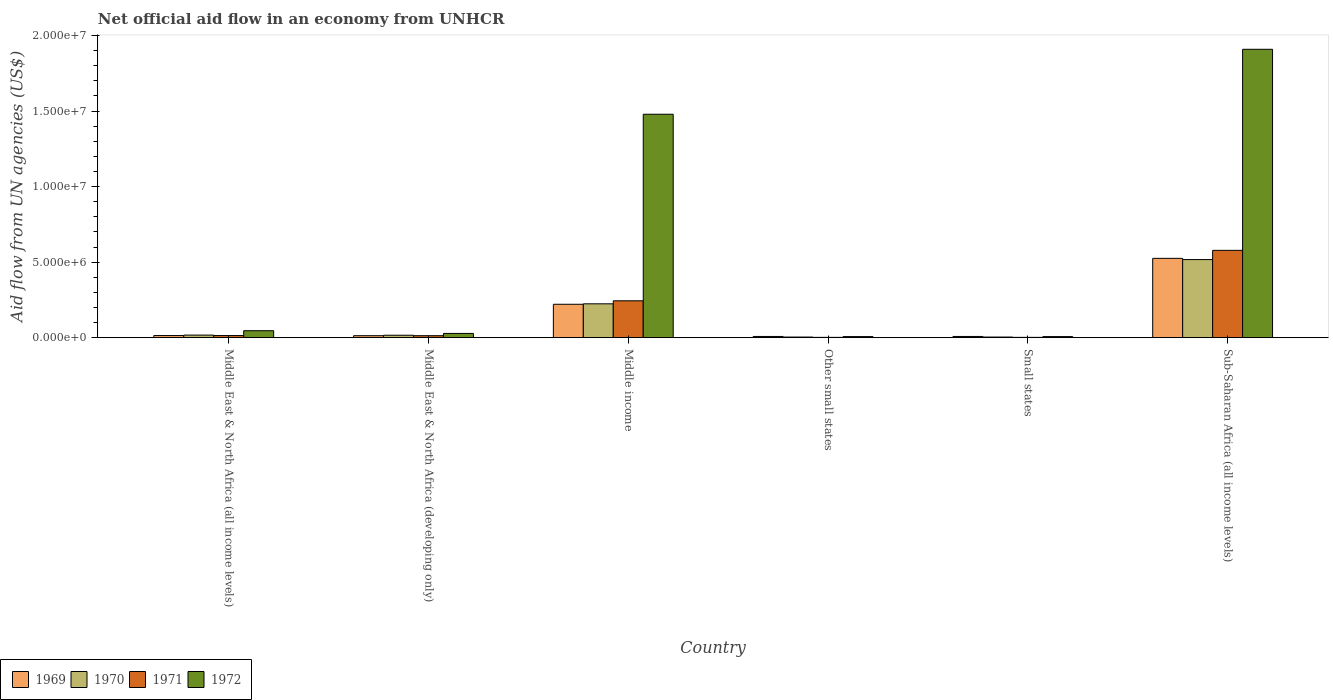How many groups of bars are there?
Your answer should be compact. 6. Are the number of bars on each tick of the X-axis equal?
Provide a succinct answer. Yes. How many bars are there on the 4th tick from the left?
Provide a short and direct response. 4. What is the label of the 2nd group of bars from the left?
Your answer should be very brief. Middle East & North Africa (developing only). What is the net official aid flow in 1970 in Middle income?
Offer a terse response. 2.24e+06. Across all countries, what is the maximum net official aid flow in 1970?
Provide a succinct answer. 5.17e+06. Across all countries, what is the minimum net official aid flow in 1970?
Ensure brevity in your answer.  4.00e+04. In which country was the net official aid flow in 1971 maximum?
Make the answer very short. Sub-Saharan Africa (all income levels). In which country was the net official aid flow in 1970 minimum?
Your answer should be very brief. Other small states. What is the total net official aid flow in 1969 in the graph?
Your answer should be compact. 7.89e+06. What is the difference between the net official aid flow in 1970 in Middle East & North Africa (developing only) and that in Small states?
Your response must be concise. 1.20e+05. What is the difference between the net official aid flow in 1971 in Middle income and the net official aid flow in 1970 in Middle East & North Africa (developing only)?
Provide a short and direct response. 2.28e+06. What is the average net official aid flow in 1972 per country?
Make the answer very short. 5.79e+06. What is the difference between the net official aid flow of/in 1971 and net official aid flow of/in 1969 in Sub-Saharan Africa (all income levels)?
Offer a very short reply. 5.30e+05. In how many countries, is the net official aid flow in 1972 greater than 17000000 US$?
Offer a very short reply. 1. What is the ratio of the net official aid flow in 1972 in Middle East & North Africa (all income levels) to that in Middle income?
Ensure brevity in your answer.  0.03. Is the net official aid flow in 1971 in Middle East & North Africa (all income levels) less than that in Sub-Saharan Africa (all income levels)?
Keep it short and to the point. Yes. What is the difference between the highest and the second highest net official aid flow in 1969?
Ensure brevity in your answer.  5.11e+06. What is the difference between the highest and the lowest net official aid flow in 1972?
Your answer should be very brief. 1.90e+07. In how many countries, is the net official aid flow in 1969 greater than the average net official aid flow in 1969 taken over all countries?
Keep it short and to the point. 2. Is the sum of the net official aid flow in 1972 in Middle East & North Africa (all income levels) and Small states greater than the maximum net official aid flow in 1969 across all countries?
Your response must be concise. No. Is it the case that in every country, the sum of the net official aid flow in 1972 and net official aid flow in 1970 is greater than the sum of net official aid flow in 1969 and net official aid flow in 1971?
Your response must be concise. No. Is it the case that in every country, the sum of the net official aid flow in 1971 and net official aid flow in 1972 is greater than the net official aid flow in 1970?
Offer a very short reply. Yes. How many bars are there?
Provide a succinct answer. 24. Are all the bars in the graph horizontal?
Keep it short and to the point. No. How many countries are there in the graph?
Offer a very short reply. 6. What is the difference between two consecutive major ticks on the Y-axis?
Give a very brief answer. 5.00e+06. What is the title of the graph?
Your response must be concise. Net official aid flow in an economy from UNHCR. What is the label or title of the X-axis?
Your response must be concise. Country. What is the label or title of the Y-axis?
Ensure brevity in your answer.  Aid flow from UN agencies (US$). What is the Aid flow from UN agencies (US$) of 1970 in Middle East & North Africa (all income levels)?
Your response must be concise. 1.70e+05. What is the Aid flow from UN agencies (US$) in 1972 in Middle East & North Africa (all income levels)?
Ensure brevity in your answer.  4.60e+05. What is the Aid flow from UN agencies (US$) of 1969 in Middle income?
Make the answer very short. 2.21e+06. What is the Aid flow from UN agencies (US$) of 1970 in Middle income?
Ensure brevity in your answer.  2.24e+06. What is the Aid flow from UN agencies (US$) in 1971 in Middle income?
Offer a terse response. 2.44e+06. What is the Aid flow from UN agencies (US$) of 1972 in Middle income?
Ensure brevity in your answer.  1.48e+07. What is the Aid flow from UN agencies (US$) in 1970 in Small states?
Ensure brevity in your answer.  4.00e+04. What is the Aid flow from UN agencies (US$) in 1972 in Small states?
Your response must be concise. 7.00e+04. What is the Aid flow from UN agencies (US$) of 1969 in Sub-Saharan Africa (all income levels)?
Provide a succinct answer. 5.25e+06. What is the Aid flow from UN agencies (US$) of 1970 in Sub-Saharan Africa (all income levels)?
Your answer should be compact. 5.17e+06. What is the Aid flow from UN agencies (US$) in 1971 in Sub-Saharan Africa (all income levels)?
Your response must be concise. 5.78e+06. What is the Aid flow from UN agencies (US$) of 1972 in Sub-Saharan Africa (all income levels)?
Keep it short and to the point. 1.91e+07. Across all countries, what is the maximum Aid flow from UN agencies (US$) in 1969?
Your answer should be compact. 5.25e+06. Across all countries, what is the maximum Aid flow from UN agencies (US$) in 1970?
Provide a short and direct response. 5.17e+06. Across all countries, what is the maximum Aid flow from UN agencies (US$) of 1971?
Provide a short and direct response. 5.78e+06. Across all countries, what is the maximum Aid flow from UN agencies (US$) in 1972?
Offer a terse response. 1.91e+07. Across all countries, what is the minimum Aid flow from UN agencies (US$) in 1970?
Ensure brevity in your answer.  4.00e+04. Across all countries, what is the minimum Aid flow from UN agencies (US$) in 1971?
Your response must be concise. 2.00e+04. Across all countries, what is the minimum Aid flow from UN agencies (US$) in 1972?
Your answer should be compact. 7.00e+04. What is the total Aid flow from UN agencies (US$) of 1969 in the graph?
Make the answer very short. 7.89e+06. What is the total Aid flow from UN agencies (US$) of 1970 in the graph?
Give a very brief answer. 7.82e+06. What is the total Aid flow from UN agencies (US$) of 1971 in the graph?
Ensure brevity in your answer.  8.53e+06. What is the total Aid flow from UN agencies (US$) of 1972 in the graph?
Offer a terse response. 3.48e+07. What is the difference between the Aid flow from UN agencies (US$) in 1969 in Middle East & North Africa (all income levels) and that in Middle East & North Africa (developing only)?
Your answer should be compact. 10000. What is the difference between the Aid flow from UN agencies (US$) of 1971 in Middle East & North Africa (all income levels) and that in Middle East & North Africa (developing only)?
Provide a succinct answer. 10000. What is the difference between the Aid flow from UN agencies (US$) of 1972 in Middle East & North Africa (all income levels) and that in Middle East & North Africa (developing only)?
Your answer should be very brief. 1.80e+05. What is the difference between the Aid flow from UN agencies (US$) in 1969 in Middle East & North Africa (all income levels) and that in Middle income?
Provide a succinct answer. -2.07e+06. What is the difference between the Aid flow from UN agencies (US$) of 1970 in Middle East & North Africa (all income levels) and that in Middle income?
Ensure brevity in your answer.  -2.07e+06. What is the difference between the Aid flow from UN agencies (US$) in 1971 in Middle East & North Africa (all income levels) and that in Middle income?
Give a very brief answer. -2.30e+06. What is the difference between the Aid flow from UN agencies (US$) of 1972 in Middle East & North Africa (all income levels) and that in Middle income?
Keep it short and to the point. -1.43e+07. What is the difference between the Aid flow from UN agencies (US$) of 1970 in Middle East & North Africa (all income levels) and that in Other small states?
Provide a succinct answer. 1.30e+05. What is the difference between the Aid flow from UN agencies (US$) of 1969 in Middle East & North Africa (all income levels) and that in Small states?
Give a very brief answer. 6.00e+04. What is the difference between the Aid flow from UN agencies (US$) in 1972 in Middle East & North Africa (all income levels) and that in Small states?
Ensure brevity in your answer.  3.90e+05. What is the difference between the Aid flow from UN agencies (US$) in 1969 in Middle East & North Africa (all income levels) and that in Sub-Saharan Africa (all income levels)?
Offer a terse response. -5.11e+06. What is the difference between the Aid flow from UN agencies (US$) of 1970 in Middle East & North Africa (all income levels) and that in Sub-Saharan Africa (all income levels)?
Your answer should be compact. -5.00e+06. What is the difference between the Aid flow from UN agencies (US$) in 1971 in Middle East & North Africa (all income levels) and that in Sub-Saharan Africa (all income levels)?
Offer a very short reply. -5.64e+06. What is the difference between the Aid flow from UN agencies (US$) of 1972 in Middle East & North Africa (all income levels) and that in Sub-Saharan Africa (all income levels)?
Provide a succinct answer. -1.86e+07. What is the difference between the Aid flow from UN agencies (US$) of 1969 in Middle East & North Africa (developing only) and that in Middle income?
Keep it short and to the point. -2.08e+06. What is the difference between the Aid flow from UN agencies (US$) in 1970 in Middle East & North Africa (developing only) and that in Middle income?
Ensure brevity in your answer.  -2.08e+06. What is the difference between the Aid flow from UN agencies (US$) in 1971 in Middle East & North Africa (developing only) and that in Middle income?
Provide a succinct answer. -2.31e+06. What is the difference between the Aid flow from UN agencies (US$) of 1972 in Middle East & North Africa (developing only) and that in Middle income?
Provide a short and direct response. -1.45e+07. What is the difference between the Aid flow from UN agencies (US$) in 1969 in Middle East & North Africa (developing only) and that in Other small states?
Provide a succinct answer. 5.00e+04. What is the difference between the Aid flow from UN agencies (US$) in 1970 in Middle East & North Africa (developing only) and that in Small states?
Your answer should be compact. 1.20e+05. What is the difference between the Aid flow from UN agencies (US$) in 1972 in Middle East & North Africa (developing only) and that in Small states?
Keep it short and to the point. 2.10e+05. What is the difference between the Aid flow from UN agencies (US$) of 1969 in Middle East & North Africa (developing only) and that in Sub-Saharan Africa (all income levels)?
Give a very brief answer. -5.12e+06. What is the difference between the Aid flow from UN agencies (US$) of 1970 in Middle East & North Africa (developing only) and that in Sub-Saharan Africa (all income levels)?
Provide a succinct answer. -5.01e+06. What is the difference between the Aid flow from UN agencies (US$) of 1971 in Middle East & North Africa (developing only) and that in Sub-Saharan Africa (all income levels)?
Ensure brevity in your answer.  -5.65e+06. What is the difference between the Aid flow from UN agencies (US$) in 1972 in Middle East & North Africa (developing only) and that in Sub-Saharan Africa (all income levels)?
Your response must be concise. -1.88e+07. What is the difference between the Aid flow from UN agencies (US$) of 1969 in Middle income and that in Other small states?
Your response must be concise. 2.13e+06. What is the difference between the Aid flow from UN agencies (US$) in 1970 in Middle income and that in Other small states?
Your response must be concise. 2.20e+06. What is the difference between the Aid flow from UN agencies (US$) of 1971 in Middle income and that in Other small states?
Offer a very short reply. 2.42e+06. What is the difference between the Aid flow from UN agencies (US$) of 1972 in Middle income and that in Other small states?
Provide a short and direct response. 1.47e+07. What is the difference between the Aid flow from UN agencies (US$) in 1969 in Middle income and that in Small states?
Offer a very short reply. 2.13e+06. What is the difference between the Aid flow from UN agencies (US$) in 1970 in Middle income and that in Small states?
Provide a succinct answer. 2.20e+06. What is the difference between the Aid flow from UN agencies (US$) in 1971 in Middle income and that in Small states?
Provide a short and direct response. 2.42e+06. What is the difference between the Aid flow from UN agencies (US$) in 1972 in Middle income and that in Small states?
Your answer should be compact. 1.47e+07. What is the difference between the Aid flow from UN agencies (US$) of 1969 in Middle income and that in Sub-Saharan Africa (all income levels)?
Make the answer very short. -3.04e+06. What is the difference between the Aid flow from UN agencies (US$) of 1970 in Middle income and that in Sub-Saharan Africa (all income levels)?
Your answer should be very brief. -2.93e+06. What is the difference between the Aid flow from UN agencies (US$) of 1971 in Middle income and that in Sub-Saharan Africa (all income levels)?
Ensure brevity in your answer.  -3.34e+06. What is the difference between the Aid flow from UN agencies (US$) of 1972 in Middle income and that in Sub-Saharan Africa (all income levels)?
Make the answer very short. -4.30e+06. What is the difference between the Aid flow from UN agencies (US$) of 1969 in Other small states and that in Small states?
Offer a terse response. 0. What is the difference between the Aid flow from UN agencies (US$) in 1971 in Other small states and that in Small states?
Your response must be concise. 0. What is the difference between the Aid flow from UN agencies (US$) of 1972 in Other small states and that in Small states?
Your answer should be very brief. 0. What is the difference between the Aid flow from UN agencies (US$) in 1969 in Other small states and that in Sub-Saharan Africa (all income levels)?
Provide a succinct answer. -5.17e+06. What is the difference between the Aid flow from UN agencies (US$) of 1970 in Other small states and that in Sub-Saharan Africa (all income levels)?
Ensure brevity in your answer.  -5.13e+06. What is the difference between the Aid flow from UN agencies (US$) in 1971 in Other small states and that in Sub-Saharan Africa (all income levels)?
Your response must be concise. -5.76e+06. What is the difference between the Aid flow from UN agencies (US$) in 1972 in Other small states and that in Sub-Saharan Africa (all income levels)?
Ensure brevity in your answer.  -1.90e+07. What is the difference between the Aid flow from UN agencies (US$) of 1969 in Small states and that in Sub-Saharan Africa (all income levels)?
Keep it short and to the point. -5.17e+06. What is the difference between the Aid flow from UN agencies (US$) of 1970 in Small states and that in Sub-Saharan Africa (all income levels)?
Make the answer very short. -5.13e+06. What is the difference between the Aid flow from UN agencies (US$) in 1971 in Small states and that in Sub-Saharan Africa (all income levels)?
Offer a very short reply. -5.76e+06. What is the difference between the Aid flow from UN agencies (US$) of 1972 in Small states and that in Sub-Saharan Africa (all income levels)?
Your answer should be compact. -1.90e+07. What is the difference between the Aid flow from UN agencies (US$) of 1971 in Middle East & North Africa (all income levels) and the Aid flow from UN agencies (US$) of 1972 in Middle East & North Africa (developing only)?
Offer a very short reply. -1.40e+05. What is the difference between the Aid flow from UN agencies (US$) in 1969 in Middle East & North Africa (all income levels) and the Aid flow from UN agencies (US$) in 1970 in Middle income?
Offer a very short reply. -2.10e+06. What is the difference between the Aid flow from UN agencies (US$) of 1969 in Middle East & North Africa (all income levels) and the Aid flow from UN agencies (US$) of 1971 in Middle income?
Provide a short and direct response. -2.30e+06. What is the difference between the Aid flow from UN agencies (US$) in 1969 in Middle East & North Africa (all income levels) and the Aid flow from UN agencies (US$) in 1972 in Middle income?
Your response must be concise. -1.46e+07. What is the difference between the Aid flow from UN agencies (US$) in 1970 in Middle East & North Africa (all income levels) and the Aid flow from UN agencies (US$) in 1971 in Middle income?
Make the answer very short. -2.27e+06. What is the difference between the Aid flow from UN agencies (US$) in 1970 in Middle East & North Africa (all income levels) and the Aid flow from UN agencies (US$) in 1972 in Middle income?
Your response must be concise. -1.46e+07. What is the difference between the Aid flow from UN agencies (US$) in 1971 in Middle East & North Africa (all income levels) and the Aid flow from UN agencies (US$) in 1972 in Middle income?
Your response must be concise. -1.46e+07. What is the difference between the Aid flow from UN agencies (US$) of 1970 in Middle East & North Africa (all income levels) and the Aid flow from UN agencies (US$) of 1971 in Other small states?
Keep it short and to the point. 1.50e+05. What is the difference between the Aid flow from UN agencies (US$) in 1970 in Middle East & North Africa (all income levels) and the Aid flow from UN agencies (US$) in 1972 in Other small states?
Your answer should be compact. 1.00e+05. What is the difference between the Aid flow from UN agencies (US$) in 1971 in Middle East & North Africa (all income levels) and the Aid flow from UN agencies (US$) in 1972 in Other small states?
Offer a terse response. 7.00e+04. What is the difference between the Aid flow from UN agencies (US$) of 1969 in Middle East & North Africa (all income levels) and the Aid flow from UN agencies (US$) of 1971 in Small states?
Keep it short and to the point. 1.20e+05. What is the difference between the Aid flow from UN agencies (US$) of 1969 in Middle East & North Africa (all income levels) and the Aid flow from UN agencies (US$) of 1972 in Small states?
Keep it short and to the point. 7.00e+04. What is the difference between the Aid flow from UN agencies (US$) in 1970 in Middle East & North Africa (all income levels) and the Aid flow from UN agencies (US$) in 1971 in Small states?
Make the answer very short. 1.50e+05. What is the difference between the Aid flow from UN agencies (US$) in 1969 in Middle East & North Africa (all income levels) and the Aid flow from UN agencies (US$) in 1970 in Sub-Saharan Africa (all income levels)?
Provide a succinct answer. -5.03e+06. What is the difference between the Aid flow from UN agencies (US$) in 1969 in Middle East & North Africa (all income levels) and the Aid flow from UN agencies (US$) in 1971 in Sub-Saharan Africa (all income levels)?
Provide a succinct answer. -5.64e+06. What is the difference between the Aid flow from UN agencies (US$) of 1969 in Middle East & North Africa (all income levels) and the Aid flow from UN agencies (US$) of 1972 in Sub-Saharan Africa (all income levels)?
Offer a terse response. -1.90e+07. What is the difference between the Aid flow from UN agencies (US$) in 1970 in Middle East & North Africa (all income levels) and the Aid flow from UN agencies (US$) in 1971 in Sub-Saharan Africa (all income levels)?
Offer a very short reply. -5.61e+06. What is the difference between the Aid flow from UN agencies (US$) in 1970 in Middle East & North Africa (all income levels) and the Aid flow from UN agencies (US$) in 1972 in Sub-Saharan Africa (all income levels)?
Keep it short and to the point. -1.89e+07. What is the difference between the Aid flow from UN agencies (US$) of 1971 in Middle East & North Africa (all income levels) and the Aid flow from UN agencies (US$) of 1972 in Sub-Saharan Africa (all income levels)?
Provide a short and direct response. -1.90e+07. What is the difference between the Aid flow from UN agencies (US$) of 1969 in Middle East & North Africa (developing only) and the Aid flow from UN agencies (US$) of 1970 in Middle income?
Provide a succinct answer. -2.11e+06. What is the difference between the Aid flow from UN agencies (US$) of 1969 in Middle East & North Africa (developing only) and the Aid flow from UN agencies (US$) of 1971 in Middle income?
Give a very brief answer. -2.31e+06. What is the difference between the Aid flow from UN agencies (US$) in 1969 in Middle East & North Africa (developing only) and the Aid flow from UN agencies (US$) in 1972 in Middle income?
Ensure brevity in your answer.  -1.47e+07. What is the difference between the Aid flow from UN agencies (US$) of 1970 in Middle East & North Africa (developing only) and the Aid flow from UN agencies (US$) of 1971 in Middle income?
Provide a short and direct response. -2.28e+06. What is the difference between the Aid flow from UN agencies (US$) of 1970 in Middle East & North Africa (developing only) and the Aid flow from UN agencies (US$) of 1972 in Middle income?
Ensure brevity in your answer.  -1.46e+07. What is the difference between the Aid flow from UN agencies (US$) of 1971 in Middle East & North Africa (developing only) and the Aid flow from UN agencies (US$) of 1972 in Middle income?
Offer a terse response. -1.47e+07. What is the difference between the Aid flow from UN agencies (US$) of 1969 in Middle East & North Africa (developing only) and the Aid flow from UN agencies (US$) of 1970 in Other small states?
Ensure brevity in your answer.  9.00e+04. What is the difference between the Aid flow from UN agencies (US$) in 1969 in Middle East & North Africa (developing only) and the Aid flow from UN agencies (US$) in 1971 in Other small states?
Give a very brief answer. 1.10e+05. What is the difference between the Aid flow from UN agencies (US$) of 1969 in Middle East & North Africa (developing only) and the Aid flow from UN agencies (US$) of 1972 in Other small states?
Your answer should be compact. 6.00e+04. What is the difference between the Aid flow from UN agencies (US$) in 1969 in Middle East & North Africa (developing only) and the Aid flow from UN agencies (US$) in 1970 in Small states?
Keep it short and to the point. 9.00e+04. What is the difference between the Aid flow from UN agencies (US$) in 1969 in Middle East & North Africa (developing only) and the Aid flow from UN agencies (US$) in 1972 in Small states?
Your answer should be compact. 6.00e+04. What is the difference between the Aid flow from UN agencies (US$) in 1970 in Middle East & North Africa (developing only) and the Aid flow from UN agencies (US$) in 1972 in Small states?
Ensure brevity in your answer.  9.00e+04. What is the difference between the Aid flow from UN agencies (US$) in 1971 in Middle East & North Africa (developing only) and the Aid flow from UN agencies (US$) in 1972 in Small states?
Keep it short and to the point. 6.00e+04. What is the difference between the Aid flow from UN agencies (US$) in 1969 in Middle East & North Africa (developing only) and the Aid flow from UN agencies (US$) in 1970 in Sub-Saharan Africa (all income levels)?
Ensure brevity in your answer.  -5.04e+06. What is the difference between the Aid flow from UN agencies (US$) of 1969 in Middle East & North Africa (developing only) and the Aid flow from UN agencies (US$) of 1971 in Sub-Saharan Africa (all income levels)?
Your response must be concise. -5.65e+06. What is the difference between the Aid flow from UN agencies (US$) in 1969 in Middle East & North Africa (developing only) and the Aid flow from UN agencies (US$) in 1972 in Sub-Saharan Africa (all income levels)?
Make the answer very short. -1.90e+07. What is the difference between the Aid flow from UN agencies (US$) of 1970 in Middle East & North Africa (developing only) and the Aid flow from UN agencies (US$) of 1971 in Sub-Saharan Africa (all income levels)?
Ensure brevity in your answer.  -5.62e+06. What is the difference between the Aid flow from UN agencies (US$) of 1970 in Middle East & North Africa (developing only) and the Aid flow from UN agencies (US$) of 1972 in Sub-Saharan Africa (all income levels)?
Offer a terse response. -1.89e+07. What is the difference between the Aid flow from UN agencies (US$) in 1971 in Middle East & North Africa (developing only) and the Aid flow from UN agencies (US$) in 1972 in Sub-Saharan Africa (all income levels)?
Ensure brevity in your answer.  -1.90e+07. What is the difference between the Aid flow from UN agencies (US$) of 1969 in Middle income and the Aid flow from UN agencies (US$) of 1970 in Other small states?
Ensure brevity in your answer.  2.17e+06. What is the difference between the Aid flow from UN agencies (US$) of 1969 in Middle income and the Aid flow from UN agencies (US$) of 1971 in Other small states?
Keep it short and to the point. 2.19e+06. What is the difference between the Aid flow from UN agencies (US$) in 1969 in Middle income and the Aid flow from UN agencies (US$) in 1972 in Other small states?
Provide a succinct answer. 2.14e+06. What is the difference between the Aid flow from UN agencies (US$) of 1970 in Middle income and the Aid flow from UN agencies (US$) of 1971 in Other small states?
Offer a very short reply. 2.22e+06. What is the difference between the Aid flow from UN agencies (US$) in 1970 in Middle income and the Aid flow from UN agencies (US$) in 1972 in Other small states?
Provide a succinct answer. 2.17e+06. What is the difference between the Aid flow from UN agencies (US$) in 1971 in Middle income and the Aid flow from UN agencies (US$) in 1972 in Other small states?
Keep it short and to the point. 2.37e+06. What is the difference between the Aid flow from UN agencies (US$) of 1969 in Middle income and the Aid flow from UN agencies (US$) of 1970 in Small states?
Your response must be concise. 2.17e+06. What is the difference between the Aid flow from UN agencies (US$) of 1969 in Middle income and the Aid flow from UN agencies (US$) of 1971 in Small states?
Offer a terse response. 2.19e+06. What is the difference between the Aid flow from UN agencies (US$) in 1969 in Middle income and the Aid flow from UN agencies (US$) in 1972 in Small states?
Offer a very short reply. 2.14e+06. What is the difference between the Aid flow from UN agencies (US$) in 1970 in Middle income and the Aid flow from UN agencies (US$) in 1971 in Small states?
Make the answer very short. 2.22e+06. What is the difference between the Aid flow from UN agencies (US$) in 1970 in Middle income and the Aid flow from UN agencies (US$) in 1972 in Small states?
Offer a terse response. 2.17e+06. What is the difference between the Aid flow from UN agencies (US$) in 1971 in Middle income and the Aid flow from UN agencies (US$) in 1972 in Small states?
Keep it short and to the point. 2.37e+06. What is the difference between the Aid flow from UN agencies (US$) in 1969 in Middle income and the Aid flow from UN agencies (US$) in 1970 in Sub-Saharan Africa (all income levels)?
Offer a very short reply. -2.96e+06. What is the difference between the Aid flow from UN agencies (US$) in 1969 in Middle income and the Aid flow from UN agencies (US$) in 1971 in Sub-Saharan Africa (all income levels)?
Provide a succinct answer. -3.57e+06. What is the difference between the Aid flow from UN agencies (US$) in 1969 in Middle income and the Aid flow from UN agencies (US$) in 1972 in Sub-Saharan Africa (all income levels)?
Ensure brevity in your answer.  -1.69e+07. What is the difference between the Aid flow from UN agencies (US$) of 1970 in Middle income and the Aid flow from UN agencies (US$) of 1971 in Sub-Saharan Africa (all income levels)?
Give a very brief answer. -3.54e+06. What is the difference between the Aid flow from UN agencies (US$) in 1970 in Middle income and the Aid flow from UN agencies (US$) in 1972 in Sub-Saharan Africa (all income levels)?
Provide a succinct answer. -1.68e+07. What is the difference between the Aid flow from UN agencies (US$) of 1971 in Middle income and the Aid flow from UN agencies (US$) of 1972 in Sub-Saharan Africa (all income levels)?
Offer a very short reply. -1.66e+07. What is the difference between the Aid flow from UN agencies (US$) of 1969 in Other small states and the Aid flow from UN agencies (US$) of 1970 in Small states?
Give a very brief answer. 4.00e+04. What is the difference between the Aid flow from UN agencies (US$) of 1969 in Other small states and the Aid flow from UN agencies (US$) of 1970 in Sub-Saharan Africa (all income levels)?
Your answer should be compact. -5.09e+06. What is the difference between the Aid flow from UN agencies (US$) of 1969 in Other small states and the Aid flow from UN agencies (US$) of 1971 in Sub-Saharan Africa (all income levels)?
Your answer should be compact. -5.70e+06. What is the difference between the Aid flow from UN agencies (US$) of 1969 in Other small states and the Aid flow from UN agencies (US$) of 1972 in Sub-Saharan Africa (all income levels)?
Your response must be concise. -1.90e+07. What is the difference between the Aid flow from UN agencies (US$) in 1970 in Other small states and the Aid flow from UN agencies (US$) in 1971 in Sub-Saharan Africa (all income levels)?
Offer a very short reply. -5.74e+06. What is the difference between the Aid flow from UN agencies (US$) in 1970 in Other small states and the Aid flow from UN agencies (US$) in 1972 in Sub-Saharan Africa (all income levels)?
Your answer should be compact. -1.90e+07. What is the difference between the Aid flow from UN agencies (US$) of 1971 in Other small states and the Aid flow from UN agencies (US$) of 1972 in Sub-Saharan Africa (all income levels)?
Make the answer very short. -1.91e+07. What is the difference between the Aid flow from UN agencies (US$) in 1969 in Small states and the Aid flow from UN agencies (US$) in 1970 in Sub-Saharan Africa (all income levels)?
Make the answer very short. -5.09e+06. What is the difference between the Aid flow from UN agencies (US$) in 1969 in Small states and the Aid flow from UN agencies (US$) in 1971 in Sub-Saharan Africa (all income levels)?
Offer a very short reply. -5.70e+06. What is the difference between the Aid flow from UN agencies (US$) of 1969 in Small states and the Aid flow from UN agencies (US$) of 1972 in Sub-Saharan Africa (all income levels)?
Your response must be concise. -1.90e+07. What is the difference between the Aid flow from UN agencies (US$) in 1970 in Small states and the Aid flow from UN agencies (US$) in 1971 in Sub-Saharan Africa (all income levels)?
Make the answer very short. -5.74e+06. What is the difference between the Aid flow from UN agencies (US$) of 1970 in Small states and the Aid flow from UN agencies (US$) of 1972 in Sub-Saharan Africa (all income levels)?
Offer a terse response. -1.90e+07. What is the difference between the Aid flow from UN agencies (US$) of 1971 in Small states and the Aid flow from UN agencies (US$) of 1972 in Sub-Saharan Africa (all income levels)?
Make the answer very short. -1.91e+07. What is the average Aid flow from UN agencies (US$) in 1969 per country?
Make the answer very short. 1.32e+06. What is the average Aid flow from UN agencies (US$) of 1970 per country?
Give a very brief answer. 1.30e+06. What is the average Aid flow from UN agencies (US$) of 1971 per country?
Provide a succinct answer. 1.42e+06. What is the average Aid flow from UN agencies (US$) in 1972 per country?
Make the answer very short. 5.79e+06. What is the difference between the Aid flow from UN agencies (US$) of 1969 and Aid flow from UN agencies (US$) of 1971 in Middle East & North Africa (all income levels)?
Provide a succinct answer. 0. What is the difference between the Aid flow from UN agencies (US$) in 1969 and Aid flow from UN agencies (US$) in 1972 in Middle East & North Africa (all income levels)?
Keep it short and to the point. -3.20e+05. What is the difference between the Aid flow from UN agencies (US$) of 1970 and Aid flow from UN agencies (US$) of 1971 in Middle East & North Africa (all income levels)?
Your response must be concise. 3.00e+04. What is the difference between the Aid flow from UN agencies (US$) of 1970 and Aid flow from UN agencies (US$) of 1972 in Middle East & North Africa (all income levels)?
Offer a very short reply. -2.90e+05. What is the difference between the Aid flow from UN agencies (US$) in 1971 and Aid flow from UN agencies (US$) in 1972 in Middle East & North Africa (all income levels)?
Offer a very short reply. -3.20e+05. What is the difference between the Aid flow from UN agencies (US$) in 1969 and Aid flow from UN agencies (US$) in 1970 in Middle East & North Africa (developing only)?
Make the answer very short. -3.00e+04. What is the difference between the Aid flow from UN agencies (US$) of 1969 and Aid flow from UN agencies (US$) of 1971 in Middle East & North Africa (developing only)?
Offer a terse response. 0. What is the difference between the Aid flow from UN agencies (US$) in 1970 and Aid flow from UN agencies (US$) in 1972 in Middle East & North Africa (developing only)?
Keep it short and to the point. -1.20e+05. What is the difference between the Aid flow from UN agencies (US$) in 1971 and Aid flow from UN agencies (US$) in 1972 in Middle East & North Africa (developing only)?
Provide a succinct answer. -1.50e+05. What is the difference between the Aid flow from UN agencies (US$) of 1969 and Aid flow from UN agencies (US$) of 1972 in Middle income?
Keep it short and to the point. -1.26e+07. What is the difference between the Aid flow from UN agencies (US$) of 1970 and Aid flow from UN agencies (US$) of 1971 in Middle income?
Your response must be concise. -2.00e+05. What is the difference between the Aid flow from UN agencies (US$) in 1970 and Aid flow from UN agencies (US$) in 1972 in Middle income?
Keep it short and to the point. -1.26e+07. What is the difference between the Aid flow from UN agencies (US$) in 1971 and Aid flow from UN agencies (US$) in 1972 in Middle income?
Make the answer very short. -1.24e+07. What is the difference between the Aid flow from UN agencies (US$) in 1969 and Aid flow from UN agencies (US$) in 1970 in Other small states?
Ensure brevity in your answer.  4.00e+04. What is the difference between the Aid flow from UN agencies (US$) in 1970 and Aid flow from UN agencies (US$) in 1972 in Other small states?
Your answer should be compact. -3.00e+04. What is the difference between the Aid flow from UN agencies (US$) of 1971 and Aid flow from UN agencies (US$) of 1972 in Other small states?
Offer a terse response. -5.00e+04. What is the difference between the Aid flow from UN agencies (US$) in 1970 and Aid flow from UN agencies (US$) in 1972 in Small states?
Offer a very short reply. -3.00e+04. What is the difference between the Aid flow from UN agencies (US$) in 1971 and Aid flow from UN agencies (US$) in 1972 in Small states?
Offer a very short reply. -5.00e+04. What is the difference between the Aid flow from UN agencies (US$) of 1969 and Aid flow from UN agencies (US$) of 1970 in Sub-Saharan Africa (all income levels)?
Offer a terse response. 8.00e+04. What is the difference between the Aid flow from UN agencies (US$) of 1969 and Aid flow from UN agencies (US$) of 1971 in Sub-Saharan Africa (all income levels)?
Provide a succinct answer. -5.30e+05. What is the difference between the Aid flow from UN agencies (US$) in 1969 and Aid flow from UN agencies (US$) in 1972 in Sub-Saharan Africa (all income levels)?
Provide a short and direct response. -1.38e+07. What is the difference between the Aid flow from UN agencies (US$) of 1970 and Aid flow from UN agencies (US$) of 1971 in Sub-Saharan Africa (all income levels)?
Offer a very short reply. -6.10e+05. What is the difference between the Aid flow from UN agencies (US$) in 1970 and Aid flow from UN agencies (US$) in 1972 in Sub-Saharan Africa (all income levels)?
Your answer should be very brief. -1.39e+07. What is the difference between the Aid flow from UN agencies (US$) of 1971 and Aid flow from UN agencies (US$) of 1972 in Sub-Saharan Africa (all income levels)?
Offer a very short reply. -1.33e+07. What is the ratio of the Aid flow from UN agencies (US$) in 1969 in Middle East & North Africa (all income levels) to that in Middle East & North Africa (developing only)?
Offer a terse response. 1.08. What is the ratio of the Aid flow from UN agencies (US$) of 1970 in Middle East & North Africa (all income levels) to that in Middle East & North Africa (developing only)?
Offer a terse response. 1.06. What is the ratio of the Aid flow from UN agencies (US$) of 1972 in Middle East & North Africa (all income levels) to that in Middle East & North Africa (developing only)?
Keep it short and to the point. 1.64. What is the ratio of the Aid flow from UN agencies (US$) of 1969 in Middle East & North Africa (all income levels) to that in Middle income?
Offer a very short reply. 0.06. What is the ratio of the Aid flow from UN agencies (US$) in 1970 in Middle East & North Africa (all income levels) to that in Middle income?
Ensure brevity in your answer.  0.08. What is the ratio of the Aid flow from UN agencies (US$) of 1971 in Middle East & North Africa (all income levels) to that in Middle income?
Offer a very short reply. 0.06. What is the ratio of the Aid flow from UN agencies (US$) of 1972 in Middle East & North Africa (all income levels) to that in Middle income?
Your answer should be very brief. 0.03. What is the ratio of the Aid flow from UN agencies (US$) in 1970 in Middle East & North Africa (all income levels) to that in Other small states?
Offer a terse response. 4.25. What is the ratio of the Aid flow from UN agencies (US$) of 1971 in Middle East & North Africa (all income levels) to that in Other small states?
Ensure brevity in your answer.  7. What is the ratio of the Aid flow from UN agencies (US$) in 1972 in Middle East & North Africa (all income levels) to that in Other small states?
Provide a short and direct response. 6.57. What is the ratio of the Aid flow from UN agencies (US$) in 1969 in Middle East & North Africa (all income levels) to that in Small states?
Offer a terse response. 1.75. What is the ratio of the Aid flow from UN agencies (US$) of 1970 in Middle East & North Africa (all income levels) to that in Small states?
Your answer should be very brief. 4.25. What is the ratio of the Aid flow from UN agencies (US$) in 1971 in Middle East & North Africa (all income levels) to that in Small states?
Give a very brief answer. 7. What is the ratio of the Aid flow from UN agencies (US$) of 1972 in Middle East & North Africa (all income levels) to that in Small states?
Provide a succinct answer. 6.57. What is the ratio of the Aid flow from UN agencies (US$) in 1969 in Middle East & North Africa (all income levels) to that in Sub-Saharan Africa (all income levels)?
Keep it short and to the point. 0.03. What is the ratio of the Aid flow from UN agencies (US$) of 1970 in Middle East & North Africa (all income levels) to that in Sub-Saharan Africa (all income levels)?
Keep it short and to the point. 0.03. What is the ratio of the Aid flow from UN agencies (US$) in 1971 in Middle East & North Africa (all income levels) to that in Sub-Saharan Africa (all income levels)?
Your answer should be compact. 0.02. What is the ratio of the Aid flow from UN agencies (US$) in 1972 in Middle East & North Africa (all income levels) to that in Sub-Saharan Africa (all income levels)?
Keep it short and to the point. 0.02. What is the ratio of the Aid flow from UN agencies (US$) of 1969 in Middle East & North Africa (developing only) to that in Middle income?
Offer a terse response. 0.06. What is the ratio of the Aid flow from UN agencies (US$) in 1970 in Middle East & North Africa (developing only) to that in Middle income?
Your answer should be compact. 0.07. What is the ratio of the Aid flow from UN agencies (US$) in 1971 in Middle East & North Africa (developing only) to that in Middle income?
Provide a short and direct response. 0.05. What is the ratio of the Aid flow from UN agencies (US$) in 1972 in Middle East & North Africa (developing only) to that in Middle income?
Your answer should be very brief. 0.02. What is the ratio of the Aid flow from UN agencies (US$) of 1969 in Middle East & North Africa (developing only) to that in Other small states?
Your answer should be very brief. 1.62. What is the ratio of the Aid flow from UN agencies (US$) in 1969 in Middle East & North Africa (developing only) to that in Small states?
Make the answer very short. 1.62. What is the ratio of the Aid flow from UN agencies (US$) in 1972 in Middle East & North Africa (developing only) to that in Small states?
Offer a very short reply. 4. What is the ratio of the Aid flow from UN agencies (US$) of 1969 in Middle East & North Africa (developing only) to that in Sub-Saharan Africa (all income levels)?
Your answer should be very brief. 0.02. What is the ratio of the Aid flow from UN agencies (US$) of 1970 in Middle East & North Africa (developing only) to that in Sub-Saharan Africa (all income levels)?
Offer a very short reply. 0.03. What is the ratio of the Aid flow from UN agencies (US$) in 1971 in Middle East & North Africa (developing only) to that in Sub-Saharan Africa (all income levels)?
Provide a succinct answer. 0.02. What is the ratio of the Aid flow from UN agencies (US$) of 1972 in Middle East & North Africa (developing only) to that in Sub-Saharan Africa (all income levels)?
Provide a short and direct response. 0.01. What is the ratio of the Aid flow from UN agencies (US$) of 1969 in Middle income to that in Other small states?
Provide a short and direct response. 27.62. What is the ratio of the Aid flow from UN agencies (US$) in 1971 in Middle income to that in Other small states?
Provide a short and direct response. 122. What is the ratio of the Aid flow from UN agencies (US$) of 1972 in Middle income to that in Other small states?
Keep it short and to the point. 211.29. What is the ratio of the Aid flow from UN agencies (US$) of 1969 in Middle income to that in Small states?
Keep it short and to the point. 27.62. What is the ratio of the Aid flow from UN agencies (US$) of 1970 in Middle income to that in Small states?
Keep it short and to the point. 56. What is the ratio of the Aid flow from UN agencies (US$) in 1971 in Middle income to that in Small states?
Make the answer very short. 122. What is the ratio of the Aid flow from UN agencies (US$) of 1972 in Middle income to that in Small states?
Offer a very short reply. 211.29. What is the ratio of the Aid flow from UN agencies (US$) in 1969 in Middle income to that in Sub-Saharan Africa (all income levels)?
Give a very brief answer. 0.42. What is the ratio of the Aid flow from UN agencies (US$) of 1970 in Middle income to that in Sub-Saharan Africa (all income levels)?
Your answer should be compact. 0.43. What is the ratio of the Aid flow from UN agencies (US$) in 1971 in Middle income to that in Sub-Saharan Africa (all income levels)?
Give a very brief answer. 0.42. What is the ratio of the Aid flow from UN agencies (US$) in 1972 in Middle income to that in Sub-Saharan Africa (all income levels)?
Your answer should be compact. 0.77. What is the ratio of the Aid flow from UN agencies (US$) in 1970 in Other small states to that in Small states?
Offer a very short reply. 1. What is the ratio of the Aid flow from UN agencies (US$) of 1972 in Other small states to that in Small states?
Provide a short and direct response. 1. What is the ratio of the Aid flow from UN agencies (US$) of 1969 in Other small states to that in Sub-Saharan Africa (all income levels)?
Offer a terse response. 0.02. What is the ratio of the Aid flow from UN agencies (US$) in 1970 in Other small states to that in Sub-Saharan Africa (all income levels)?
Provide a short and direct response. 0.01. What is the ratio of the Aid flow from UN agencies (US$) of 1971 in Other small states to that in Sub-Saharan Africa (all income levels)?
Your answer should be very brief. 0. What is the ratio of the Aid flow from UN agencies (US$) of 1972 in Other small states to that in Sub-Saharan Africa (all income levels)?
Offer a very short reply. 0. What is the ratio of the Aid flow from UN agencies (US$) in 1969 in Small states to that in Sub-Saharan Africa (all income levels)?
Your answer should be compact. 0.02. What is the ratio of the Aid flow from UN agencies (US$) in 1970 in Small states to that in Sub-Saharan Africa (all income levels)?
Provide a succinct answer. 0.01. What is the ratio of the Aid flow from UN agencies (US$) of 1971 in Small states to that in Sub-Saharan Africa (all income levels)?
Offer a very short reply. 0. What is the ratio of the Aid flow from UN agencies (US$) of 1972 in Small states to that in Sub-Saharan Africa (all income levels)?
Ensure brevity in your answer.  0. What is the difference between the highest and the second highest Aid flow from UN agencies (US$) of 1969?
Your answer should be compact. 3.04e+06. What is the difference between the highest and the second highest Aid flow from UN agencies (US$) of 1970?
Keep it short and to the point. 2.93e+06. What is the difference between the highest and the second highest Aid flow from UN agencies (US$) in 1971?
Make the answer very short. 3.34e+06. What is the difference between the highest and the second highest Aid flow from UN agencies (US$) of 1972?
Offer a very short reply. 4.30e+06. What is the difference between the highest and the lowest Aid flow from UN agencies (US$) in 1969?
Make the answer very short. 5.17e+06. What is the difference between the highest and the lowest Aid flow from UN agencies (US$) of 1970?
Your answer should be very brief. 5.13e+06. What is the difference between the highest and the lowest Aid flow from UN agencies (US$) of 1971?
Your response must be concise. 5.76e+06. What is the difference between the highest and the lowest Aid flow from UN agencies (US$) of 1972?
Offer a terse response. 1.90e+07. 